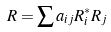<formula> <loc_0><loc_0><loc_500><loc_500>R = \sum a _ { i j } R _ { i } ^ { * } R _ { j }</formula> 